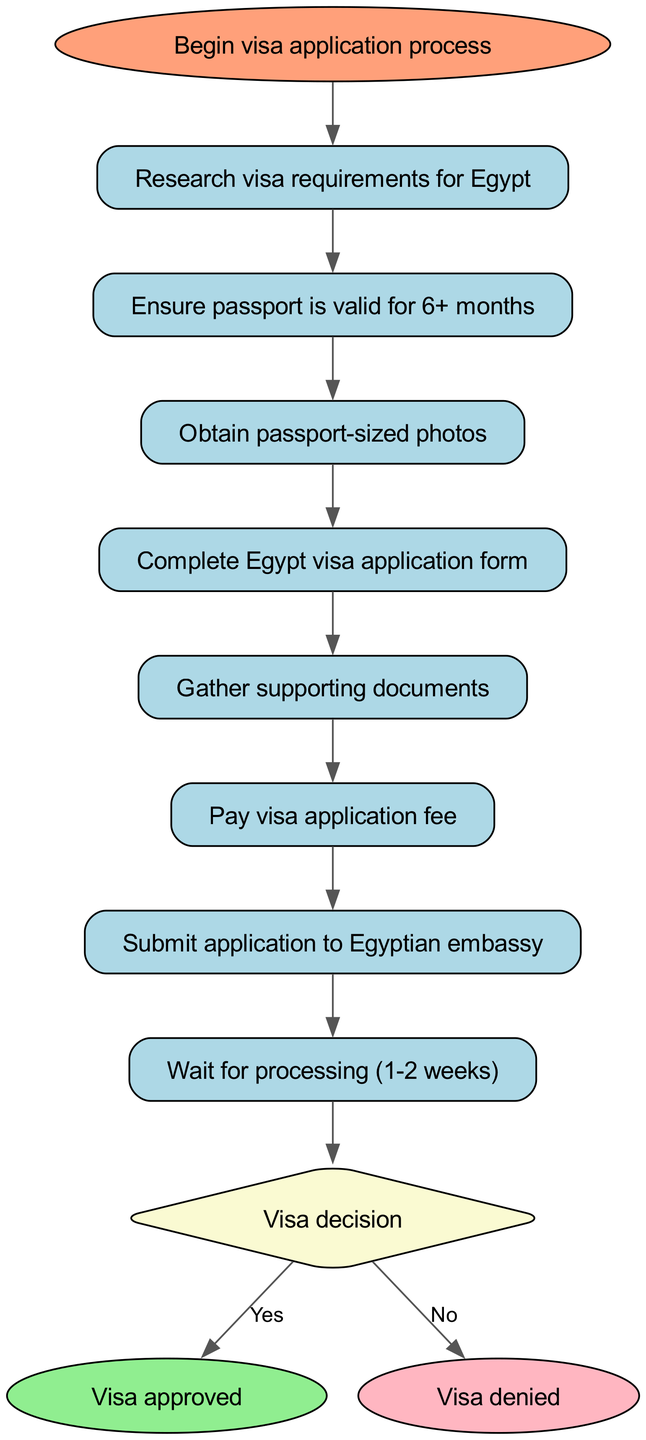What is the first step in the visa application process? The diagram indicates that the first step is "Begin visa application process." Thus, this is the initial action to take in the flowchart.
Answer: Begin visa application process How many nodes are present in the diagram? By counting the unique steps or actions depicted, there are 12 nodes listed in the data: start, research, passport, photos, form, documents, fee, submit, wait, decision, approved, and denied.
Answer: 12 What document is required to ensure eligibility for the visa application? The node corresponding to eligibility states "Ensure passport is valid for 6+ months." This highlights the necessity of a valid passport for the process.
Answer: Ensure passport is valid for 6+ months What do you do after gathering supporting documents? The diagram shows that after gathering documents, the next step is "Pay visa application fee." This indicates a sequential progression in the application process.
Answer: Pay visa application fee What happens after waiting for processing? Once the waiting period is complete (1-2 weeks), the next step is "Visa decision," meaning that you will receive a decision on your application.
Answer: Visa decision If the visa is denied, which step leads to that result? According to the flowchart, the decision node leads to "denied" if the application is not approved. Thus, the direct pathway can be traced through the decision node.
Answer: denied What is the outcome if the visa is approved? The flowchart indicates that being successful in the visa application process leads to the outcome noted as "Visa approved." This represents a successful result of the application.
Answer: Visa approved What could be a potential hindrance in the application process? Although not explicitly stated in the nodes, potential hurdles could arise at various stages, particularly during "Submit application to Egyptian embassy," involving documentation errors or insufficient information.
Answer: submission issues 